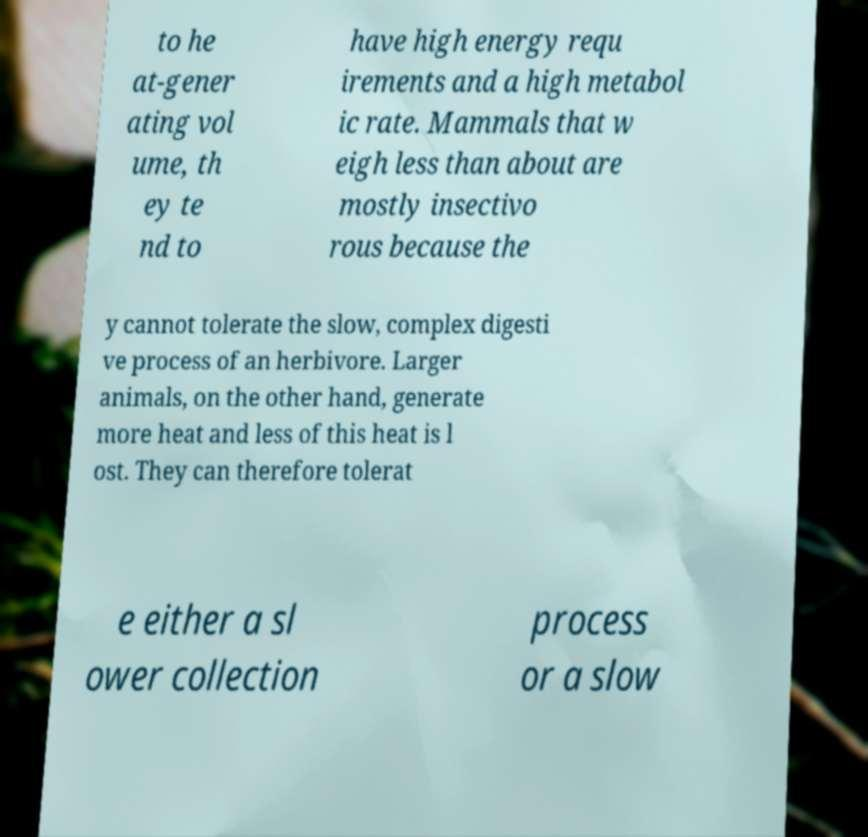Could you assist in decoding the text presented in this image and type it out clearly? to he at-gener ating vol ume, th ey te nd to have high energy requ irements and a high metabol ic rate. Mammals that w eigh less than about are mostly insectivo rous because the y cannot tolerate the slow, complex digesti ve process of an herbivore. Larger animals, on the other hand, generate more heat and less of this heat is l ost. They can therefore tolerat e either a sl ower collection process or a slow 